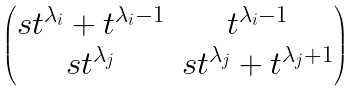<formula> <loc_0><loc_0><loc_500><loc_500>\begin{pmatrix} s t ^ { \lambda _ { i } } + t ^ { \lambda _ { i } - 1 } & t ^ { \lambda _ { i } - 1 } \\ s t ^ { \lambda _ { j } } & s t ^ { \lambda _ { j } } + t ^ { \lambda _ { j } + 1 } \end{pmatrix}</formula> 